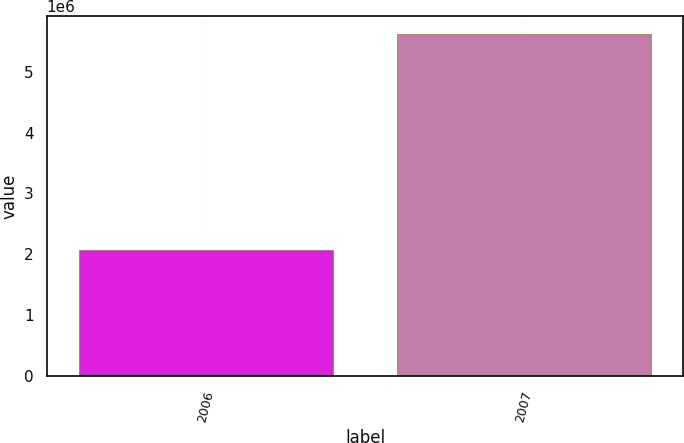<chart> <loc_0><loc_0><loc_500><loc_500><bar_chart><fcel>2006<fcel>2007<nl><fcel>2.07616e+06<fcel>5.62509e+06<nl></chart> 